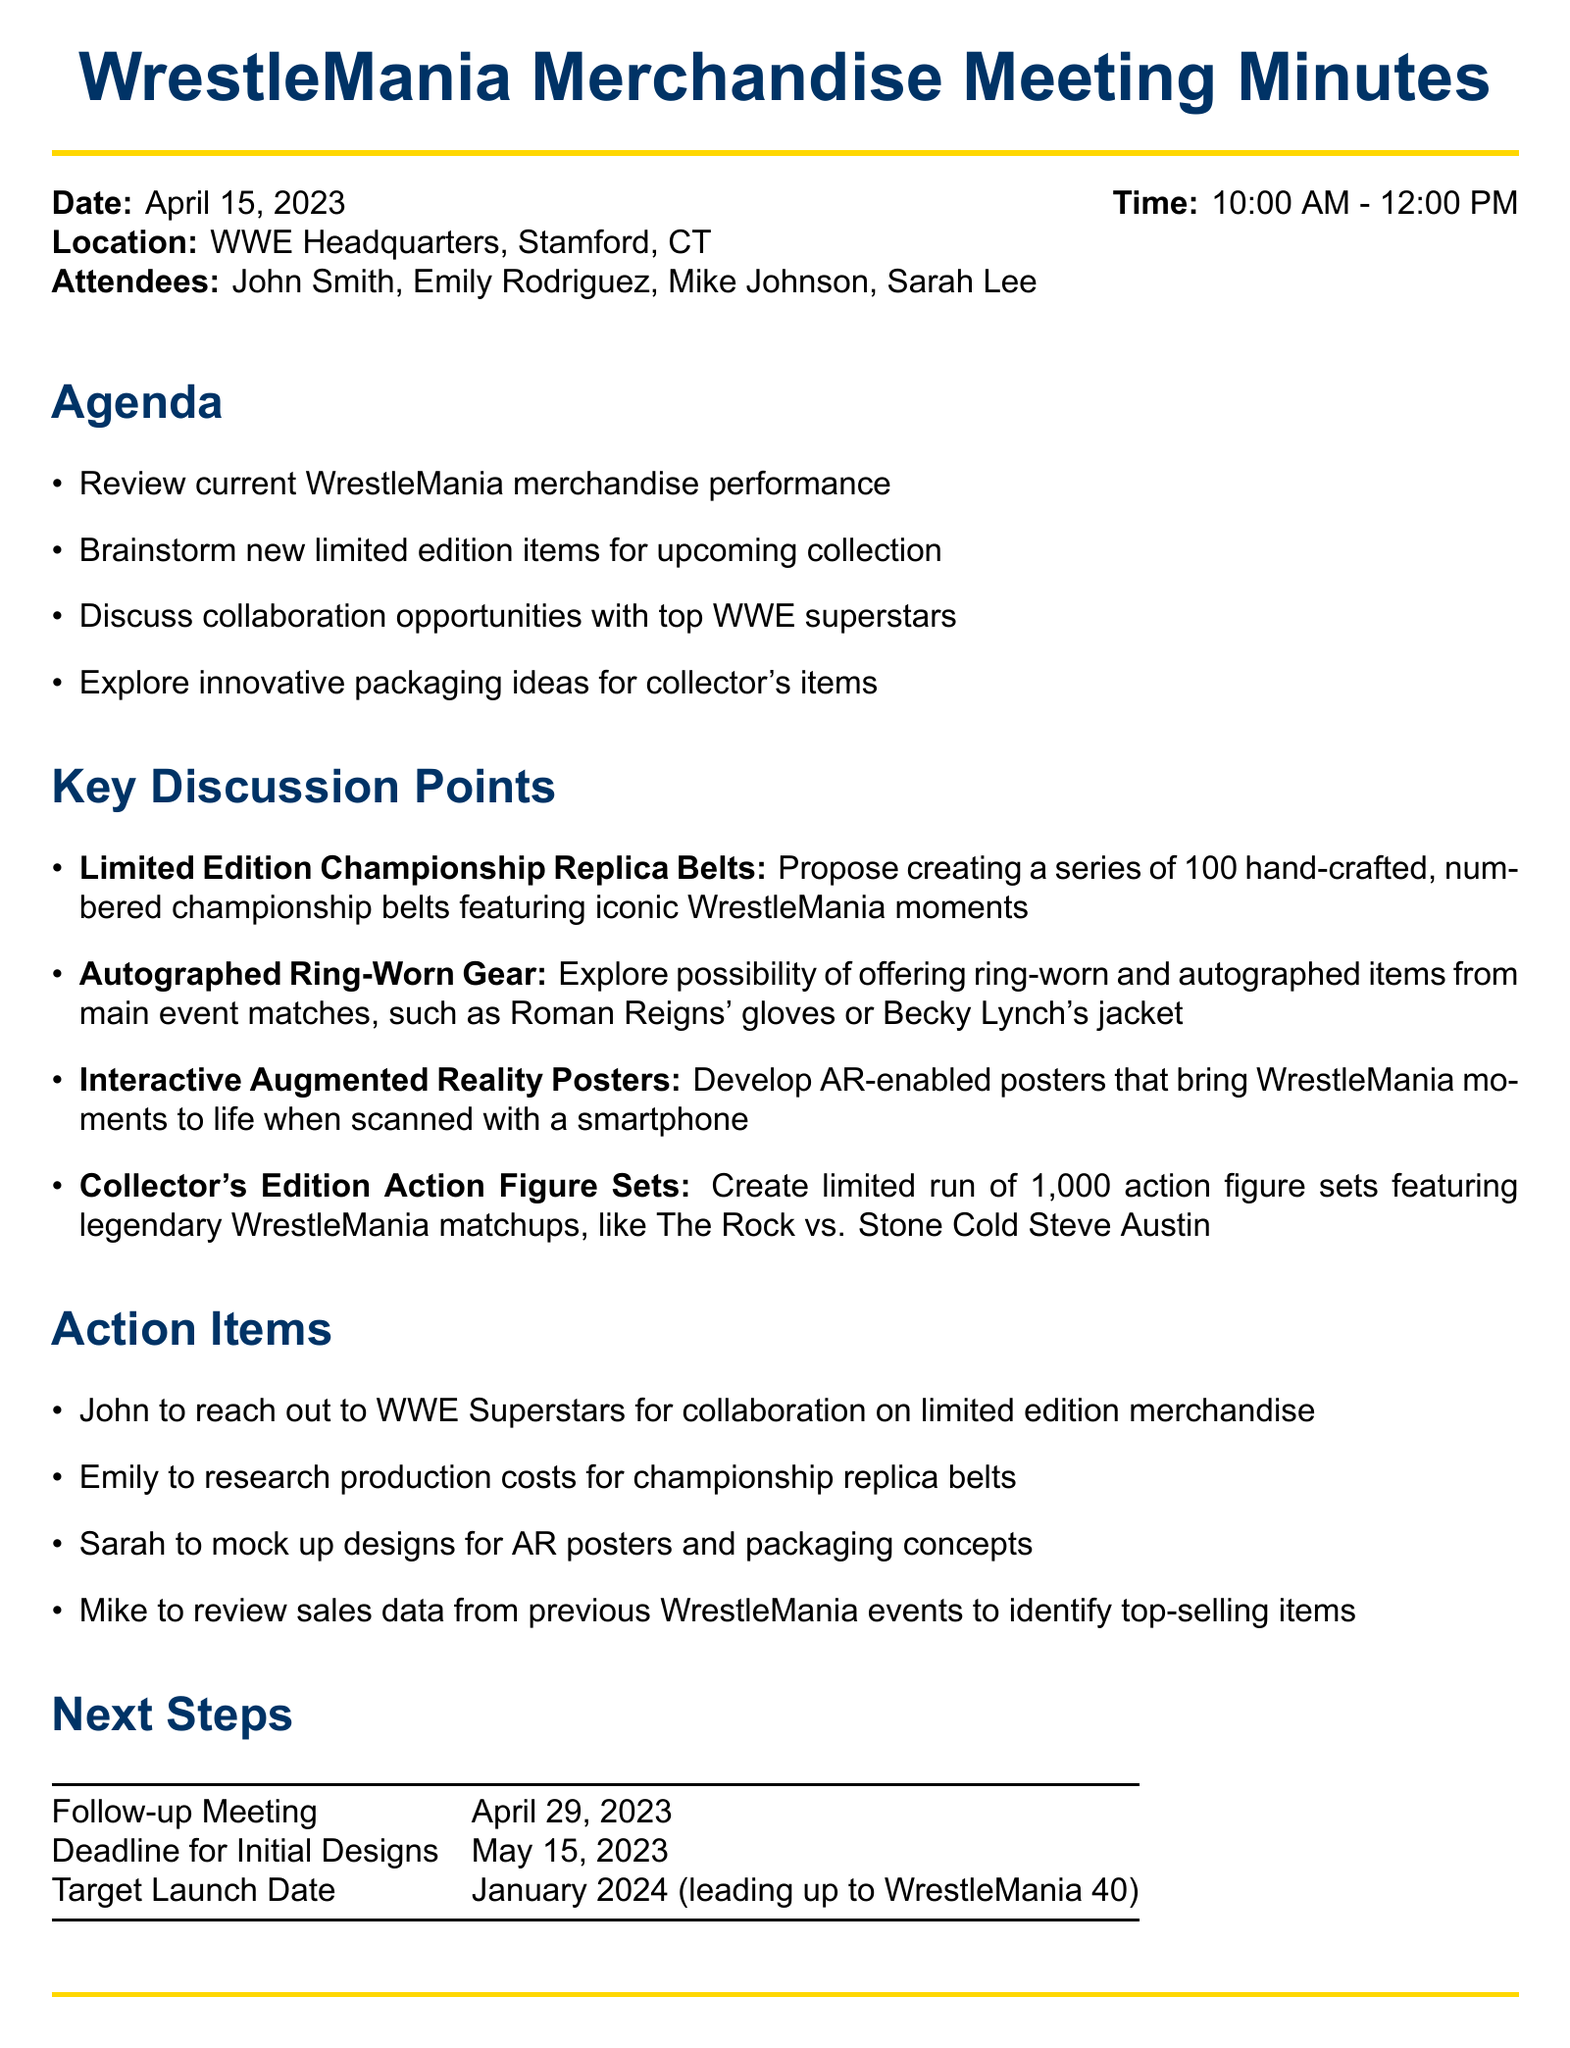What is the date of the meeting? The date of the meeting is explicitly mentioned in the meeting details section.
Answer: April 15, 2023 Who was the Product Development Manager in the meeting? The attendees section lists the individuals present at the meeting along with their roles, including the Product Development Manager.
Answer: Emily Rodriguez What is one proposed limited edition item discussed? The key discussion points elaborate on various limited edition items, one of which is specified.
Answer: Limited Edition Championship Replica Belts How many action figure sets are planned for the limited run? The details for the Collector's Edition Action Figure Sets specify the number of sets planned.
Answer: 1,000 When is the next follow-up meeting scheduled? The next steps section outlines subsequent actions, including the date for the follow-up meeting.
Answer: April 29, 2023 What action is John responsible for? The action items list specific responsibilities assigned to individuals, including John's task.
Answer: Reach out to WWE Superstars for collaboration Which aspect of merchandise is being explored according to the agenda? The agenda items identify various areas under discussion, including those related to the merchandising strategy.
Answer: Limited edition items 